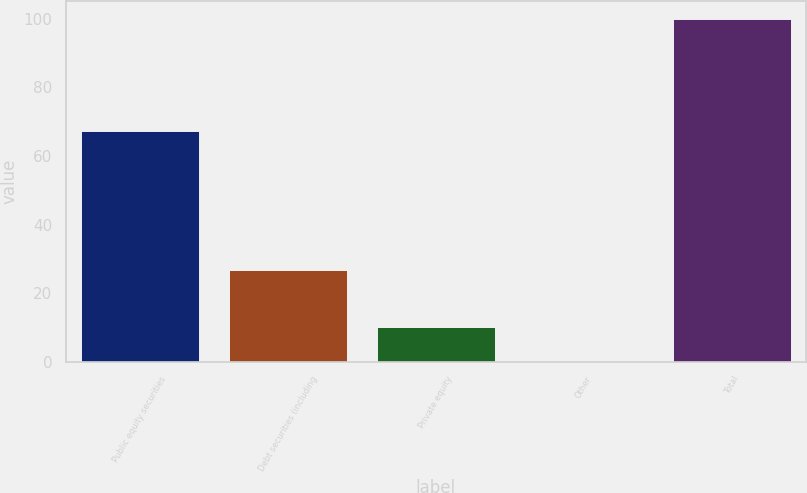<chart> <loc_0><loc_0><loc_500><loc_500><bar_chart><fcel>Public equity securities<fcel>Debt securities (including<fcel>Private equity<fcel>Other<fcel>Total<nl><fcel>67.3<fcel>26.8<fcel>10.27<fcel>0.3<fcel>100<nl></chart> 